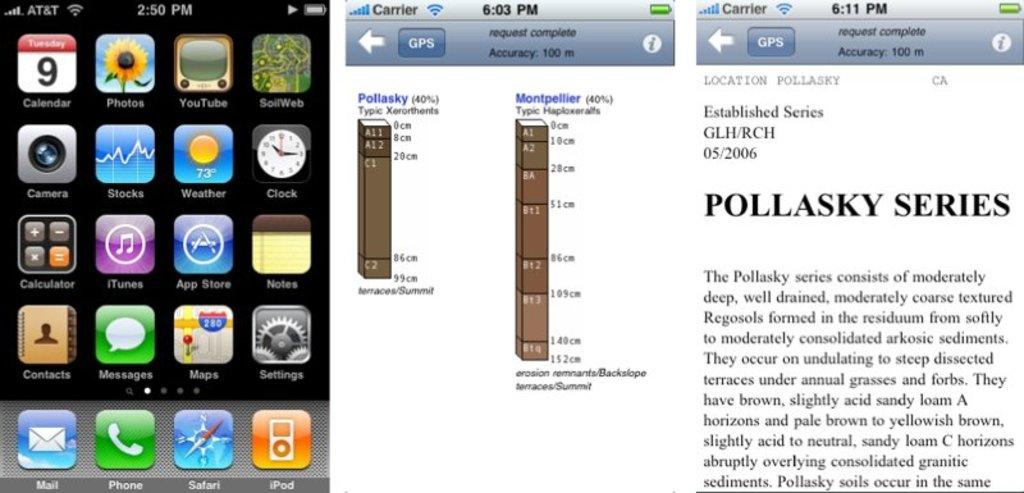<image>
Summarize the visual content of the image. The date shown on the phone is Tuesday the ninth 